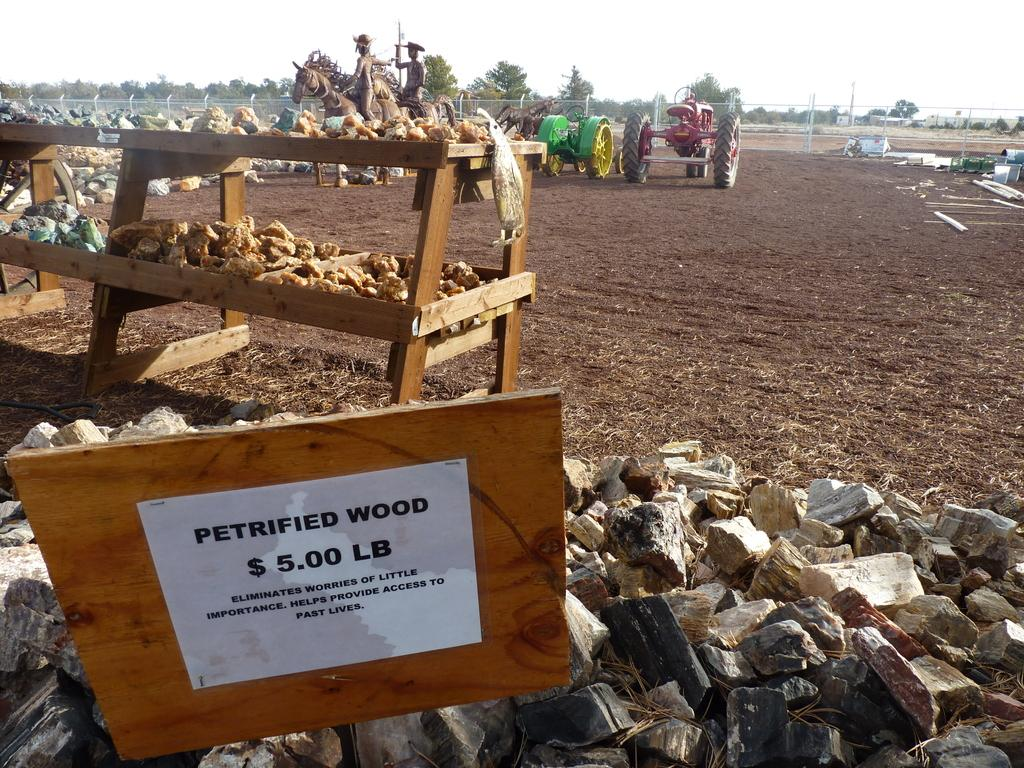Provide a one-sentence caption for the provided image. A pile of petrified wood for $5.00 lb. outside in a field. 